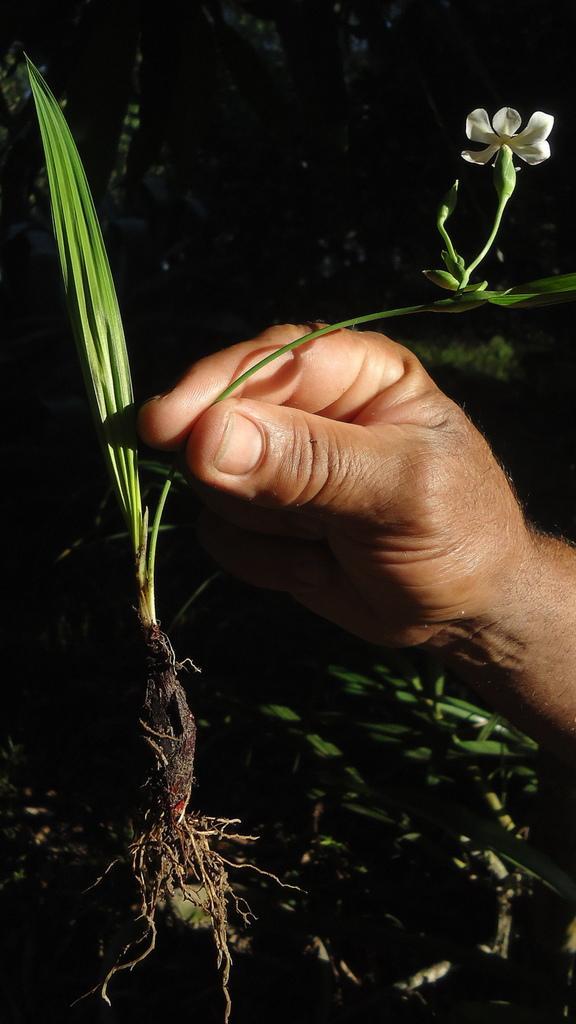Please provide a concise description of this image. In this image, we can see the hand of a person holding a plant. We can see the ground with some leaves. We can also see the dark background. 